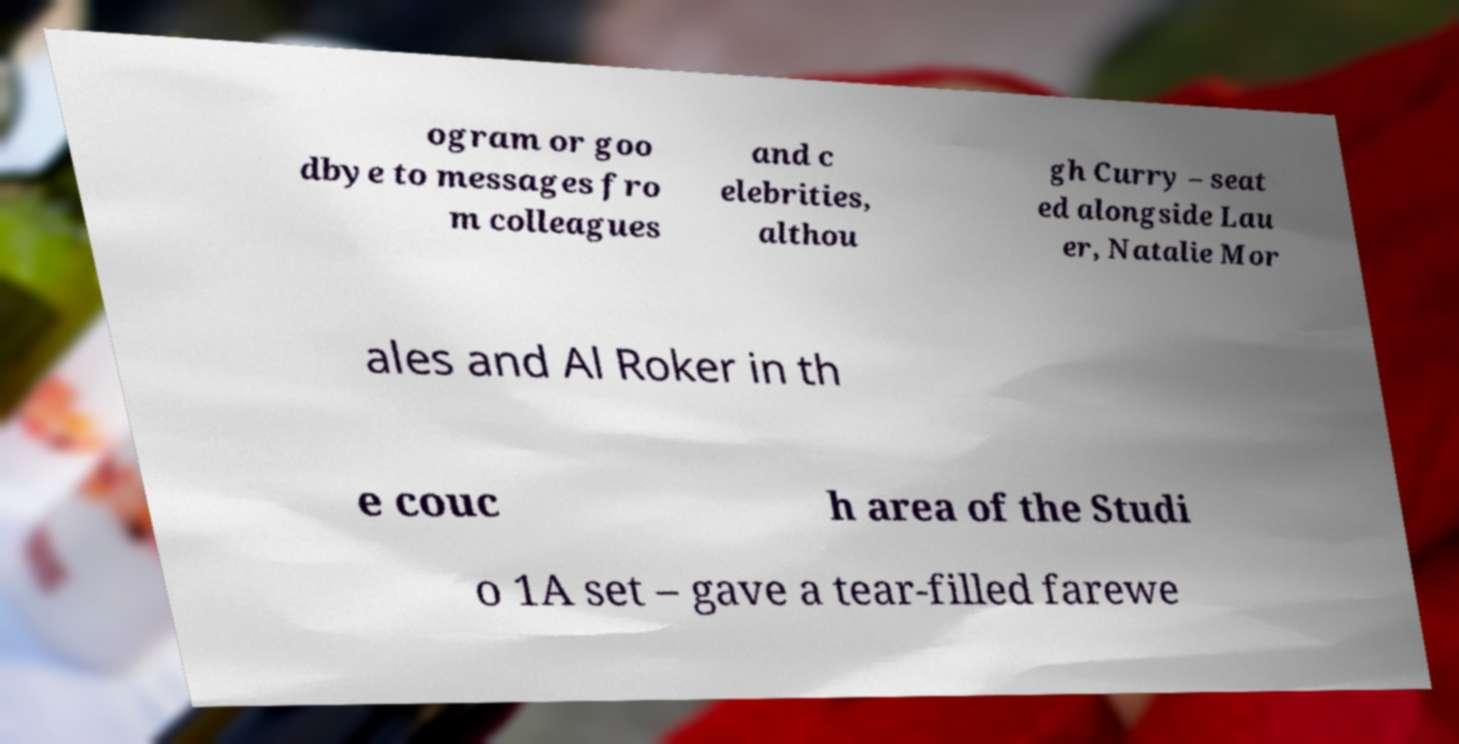What messages or text are displayed in this image? I need them in a readable, typed format. ogram or goo dbye to messages fro m colleagues and c elebrities, althou gh Curry – seat ed alongside Lau er, Natalie Mor ales and Al Roker in th e couc h area of the Studi o 1A set – gave a tear-filled farewe 